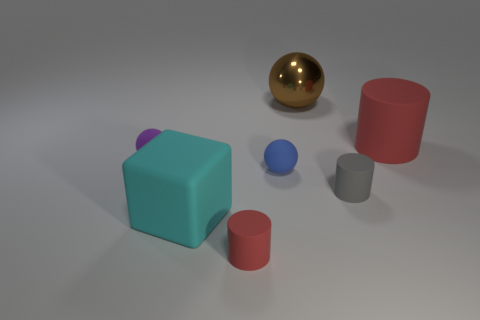Does the image depict a realistic setting? The setting is not completely realistic as the objects are shown floating above the surface, ignoring the effects of gravity which doesn't occur in real-world environments. What does the arrangement of these objects suggest? The varied positioning and sizes of objects suggest a deliberate arrangement for illustrative or artistic purposes, possibly to demonstrate perspectives, shapes, or color contrasts. 